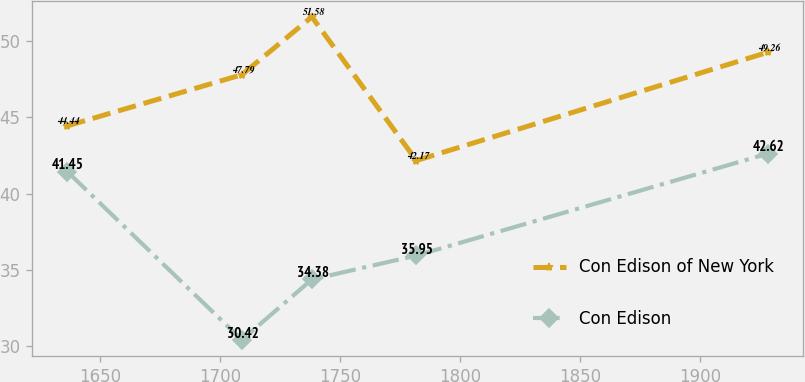<chart> <loc_0><loc_0><loc_500><loc_500><line_chart><ecel><fcel>Con Edison of New York<fcel>Con Edison<nl><fcel>1636.19<fcel>44.44<fcel>41.45<nl><fcel>1708.98<fcel>47.79<fcel>30.42<nl><fcel>1738.19<fcel>51.58<fcel>34.38<nl><fcel>1781.78<fcel>42.17<fcel>35.95<nl><fcel>1928.26<fcel>49.26<fcel>42.62<nl></chart> 